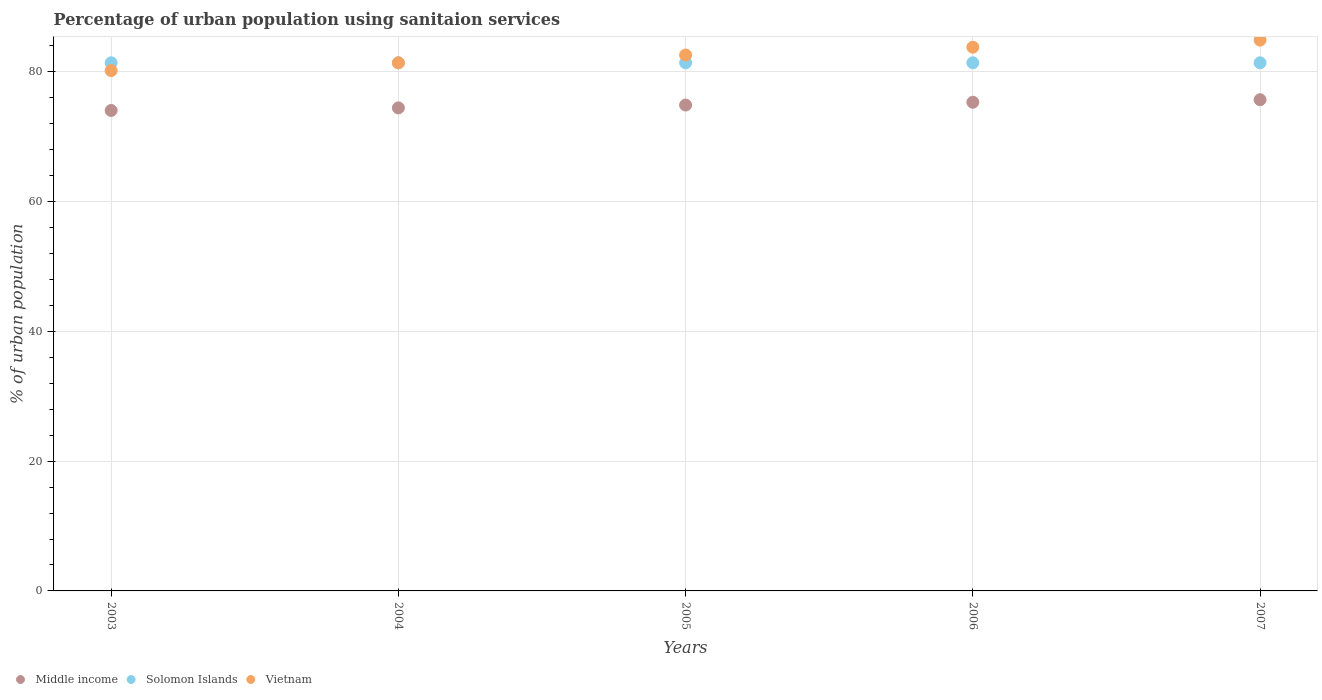What is the percentage of urban population using sanitaion services in Solomon Islands in 2005?
Ensure brevity in your answer.  81.4. Across all years, what is the maximum percentage of urban population using sanitaion services in Vietnam?
Provide a short and direct response. 84.9. Across all years, what is the minimum percentage of urban population using sanitaion services in Middle income?
Offer a very short reply. 74.05. What is the total percentage of urban population using sanitaion services in Solomon Islands in the graph?
Make the answer very short. 407. What is the difference between the percentage of urban population using sanitaion services in Solomon Islands in 2004 and that in 2007?
Make the answer very short. 0. What is the difference between the percentage of urban population using sanitaion services in Solomon Islands in 2003 and the percentage of urban population using sanitaion services in Vietnam in 2005?
Make the answer very short. -1.2. What is the average percentage of urban population using sanitaion services in Solomon Islands per year?
Your answer should be compact. 81.4. In the year 2003, what is the difference between the percentage of urban population using sanitaion services in Vietnam and percentage of urban population using sanitaion services in Solomon Islands?
Your response must be concise. -1.2. In how many years, is the percentage of urban population using sanitaion services in Vietnam greater than 28 %?
Offer a terse response. 5. Is the percentage of urban population using sanitaion services in Solomon Islands in 2003 less than that in 2004?
Offer a terse response. No. Is the sum of the percentage of urban population using sanitaion services in Solomon Islands in 2003 and 2004 greater than the maximum percentage of urban population using sanitaion services in Middle income across all years?
Ensure brevity in your answer.  Yes. Is it the case that in every year, the sum of the percentage of urban population using sanitaion services in Vietnam and percentage of urban population using sanitaion services in Middle income  is greater than the percentage of urban population using sanitaion services in Solomon Islands?
Provide a short and direct response. Yes. Does the percentage of urban population using sanitaion services in Vietnam monotonically increase over the years?
Give a very brief answer. Yes. Is the percentage of urban population using sanitaion services in Solomon Islands strictly greater than the percentage of urban population using sanitaion services in Middle income over the years?
Ensure brevity in your answer.  Yes. Is the percentage of urban population using sanitaion services in Middle income strictly less than the percentage of urban population using sanitaion services in Vietnam over the years?
Offer a very short reply. Yes. How many dotlines are there?
Offer a very short reply. 3. Where does the legend appear in the graph?
Offer a very short reply. Bottom left. How many legend labels are there?
Make the answer very short. 3. How are the legend labels stacked?
Your answer should be very brief. Horizontal. What is the title of the graph?
Keep it short and to the point. Percentage of urban population using sanitaion services. Does "Marshall Islands" appear as one of the legend labels in the graph?
Offer a very short reply. No. What is the label or title of the Y-axis?
Your answer should be compact. % of urban population. What is the % of urban population in Middle income in 2003?
Offer a terse response. 74.05. What is the % of urban population of Solomon Islands in 2003?
Your answer should be very brief. 81.4. What is the % of urban population of Vietnam in 2003?
Keep it short and to the point. 80.2. What is the % of urban population of Middle income in 2004?
Your answer should be compact. 74.45. What is the % of urban population in Solomon Islands in 2004?
Give a very brief answer. 81.4. What is the % of urban population in Vietnam in 2004?
Provide a succinct answer. 81.4. What is the % of urban population in Middle income in 2005?
Your answer should be very brief. 74.89. What is the % of urban population of Solomon Islands in 2005?
Provide a short and direct response. 81.4. What is the % of urban population in Vietnam in 2005?
Offer a very short reply. 82.6. What is the % of urban population in Middle income in 2006?
Offer a very short reply. 75.32. What is the % of urban population of Solomon Islands in 2006?
Provide a succinct answer. 81.4. What is the % of urban population of Vietnam in 2006?
Offer a very short reply. 83.8. What is the % of urban population of Middle income in 2007?
Your answer should be very brief. 75.71. What is the % of urban population of Solomon Islands in 2007?
Offer a terse response. 81.4. What is the % of urban population in Vietnam in 2007?
Provide a short and direct response. 84.9. Across all years, what is the maximum % of urban population in Middle income?
Your answer should be very brief. 75.71. Across all years, what is the maximum % of urban population in Solomon Islands?
Provide a short and direct response. 81.4. Across all years, what is the maximum % of urban population of Vietnam?
Make the answer very short. 84.9. Across all years, what is the minimum % of urban population in Middle income?
Your answer should be very brief. 74.05. Across all years, what is the minimum % of urban population in Solomon Islands?
Provide a succinct answer. 81.4. Across all years, what is the minimum % of urban population in Vietnam?
Offer a very short reply. 80.2. What is the total % of urban population of Middle income in the graph?
Provide a short and direct response. 374.42. What is the total % of urban population in Solomon Islands in the graph?
Your answer should be compact. 407. What is the total % of urban population in Vietnam in the graph?
Keep it short and to the point. 412.9. What is the difference between the % of urban population of Middle income in 2003 and that in 2004?
Provide a short and direct response. -0.4. What is the difference between the % of urban population in Solomon Islands in 2003 and that in 2004?
Give a very brief answer. 0. What is the difference between the % of urban population of Middle income in 2003 and that in 2005?
Offer a very short reply. -0.84. What is the difference between the % of urban population in Middle income in 2003 and that in 2006?
Your response must be concise. -1.27. What is the difference between the % of urban population in Solomon Islands in 2003 and that in 2006?
Ensure brevity in your answer.  0. What is the difference between the % of urban population of Middle income in 2003 and that in 2007?
Your response must be concise. -1.66. What is the difference between the % of urban population of Vietnam in 2003 and that in 2007?
Make the answer very short. -4.7. What is the difference between the % of urban population of Middle income in 2004 and that in 2005?
Keep it short and to the point. -0.44. What is the difference between the % of urban population in Solomon Islands in 2004 and that in 2005?
Your answer should be very brief. 0. What is the difference between the % of urban population of Vietnam in 2004 and that in 2005?
Offer a terse response. -1.2. What is the difference between the % of urban population of Middle income in 2004 and that in 2006?
Make the answer very short. -0.87. What is the difference between the % of urban population in Vietnam in 2004 and that in 2006?
Make the answer very short. -2.4. What is the difference between the % of urban population of Middle income in 2004 and that in 2007?
Offer a terse response. -1.26. What is the difference between the % of urban population of Solomon Islands in 2004 and that in 2007?
Give a very brief answer. 0. What is the difference between the % of urban population of Middle income in 2005 and that in 2006?
Provide a succinct answer. -0.43. What is the difference between the % of urban population in Solomon Islands in 2005 and that in 2006?
Your answer should be very brief. 0. What is the difference between the % of urban population of Middle income in 2005 and that in 2007?
Keep it short and to the point. -0.82. What is the difference between the % of urban population in Middle income in 2006 and that in 2007?
Your answer should be very brief. -0.39. What is the difference between the % of urban population in Vietnam in 2006 and that in 2007?
Your answer should be compact. -1.1. What is the difference between the % of urban population of Middle income in 2003 and the % of urban population of Solomon Islands in 2004?
Make the answer very short. -7.35. What is the difference between the % of urban population of Middle income in 2003 and the % of urban population of Vietnam in 2004?
Provide a succinct answer. -7.35. What is the difference between the % of urban population of Solomon Islands in 2003 and the % of urban population of Vietnam in 2004?
Keep it short and to the point. 0. What is the difference between the % of urban population in Middle income in 2003 and the % of urban population in Solomon Islands in 2005?
Keep it short and to the point. -7.35. What is the difference between the % of urban population of Middle income in 2003 and the % of urban population of Vietnam in 2005?
Your answer should be very brief. -8.55. What is the difference between the % of urban population of Middle income in 2003 and the % of urban population of Solomon Islands in 2006?
Provide a succinct answer. -7.35. What is the difference between the % of urban population in Middle income in 2003 and the % of urban population in Vietnam in 2006?
Keep it short and to the point. -9.75. What is the difference between the % of urban population of Solomon Islands in 2003 and the % of urban population of Vietnam in 2006?
Give a very brief answer. -2.4. What is the difference between the % of urban population in Middle income in 2003 and the % of urban population in Solomon Islands in 2007?
Your answer should be compact. -7.35. What is the difference between the % of urban population in Middle income in 2003 and the % of urban population in Vietnam in 2007?
Offer a terse response. -10.85. What is the difference between the % of urban population in Middle income in 2004 and the % of urban population in Solomon Islands in 2005?
Your response must be concise. -6.95. What is the difference between the % of urban population of Middle income in 2004 and the % of urban population of Vietnam in 2005?
Ensure brevity in your answer.  -8.15. What is the difference between the % of urban population of Solomon Islands in 2004 and the % of urban population of Vietnam in 2005?
Make the answer very short. -1.2. What is the difference between the % of urban population in Middle income in 2004 and the % of urban population in Solomon Islands in 2006?
Keep it short and to the point. -6.95. What is the difference between the % of urban population of Middle income in 2004 and the % of urban population of Vietnam in 2006?
Your response must be concise. -9.35. What is the difference between the % of urban population in Solomon Islands in 2004 and the % of urban population in Vietnam in 2006?
Ensure brevity in your answer.  -2.4. What is the difference between the % of urban population in Middle income in 2004 and the % of urban population in Solomon Islands in 2007?
Ensure brevity in your answer.  -6.95. What is the difference between the % of urban population of Middle income in 2004 and the % of urban population of Vietnam in 2007?
Your answer should be compact. -10.45. What is the difference between the % of urban population of Middle income in 2005 and the % of urban population of Solomon Islands in 2006?
Give a very brief answer. -6.51. What is the difference between the % of urban population of Middle income in 2005 and the % of urban population of Vietnam in 2006?
Provide a succinct answer. -8.91. What is the difference between the % of urban population of Middle income in 2005 and the % of urban population of Solomon Islands in 2007?
Keep it short and to the point. -6.51. What is the difference between the % of urban population of Middle income in 2005 and the % of urban population of Vietnam in 2007?
Your response must be concise. -10.01. What is the difference between the % of urban population in Middle income in 2006 and the % of urban population in Solomon Islands in 2007?
Your answer should be very brief. -6.08. What is the difference between the % of urban population of Middle income in 2006 and the % of urban population of Vietnam in 2007?
Provide a succinct answer. -9.58. What is the average % of urban population in Middle income per year?
Offer a very short reply. 74.88. What is the average % of urban population of Solomon Islands per year?
Keep it short and to the point. 81.4. What is the average % of urban population of Vietnam per year?
Provide a succinct answer. 82.58. In the year 2003, what is the difference between the % of urban population in Middle income and % of urban population in Solomon Islands?
Your answer should be compact. -7.35. In the year 2003, what is the difference between the % of urban population of Middle income and % of urban population of Vietnam?
Provide a short and direct response. -6.15. In the year 2003, what is the difference between the % of urban population of Solomon Islands and % of urban population of Vietnam?
Give a very brief answer. 1.2. In the year 2004, what is the difference between the % of urban population in Middle income and % of urban population in Solomon Islands?
Keep it short and to the point. -6.95. In the year 2004, what is the difference between the % of urban population in Middle income and % of urban population in Vietnam?
Offer a terse response. -6.95. In the year 2005, what is the difference between the % of urban population of Middle income and % of urban population of Solomon Islands?
Ensure brevity in your answer.  -6.51. In the year 2005, what is the difference between the % of urban population in Middle income and % of urban population in Vietnam?
Make the answer very short. -7.71. In the year 2005, what is the difference between the % of urban population in Solomon Islands and % of urban population in Vietnam?
Offer a very short reply. -1.2. In the year 2006, what is the difference between the % of urban population of Middle income and % of urban population of Solomon Islands?
Your response must be concise. -6.08. In the year 2006, what is the difference between the % of urban population in Middle income and % of urban population in Vietnam?
Ensure brevity in your answer.  -8.48. In the year 2006, what is the difference between the % of urban population of Solomon Islands and % of urban population of Vietnam?
Provide a short and direct response. -2.4. In the year 2007, what is the difference between the % of urban population of Middle income and % of urban population of Solomon Islands?
Give a very brief answer. -5.69. In the year 2007, what is the difference between the % of urban population in Middle income and % of urban population in Vietnam?
Your answer should be compact. -9.19. What is the ratio of the % of urban population in Solomon Islands in 2003 to that in 2004?
Ensure brevity in your answer.  1. What is the ratio of the % of urban population in Vietnam in 2003 to that in 2004?
Provide a succinct answer. 0.99. What is the ratio of the % of urban population of Solomon Islands in 2003 to that in 2005?
Ensure brevity in your answer.  1. What is the ratio of the % of urban population in Vietnam in 2003 to that in 2005?
Ensure brevity in your answer.  0.97. What is the ratio of the % of urban population of Middle income in 2003 to that in 2006?
Provide a short and direct response. 0.98. What is the ratio of the % of urban population of Solomon Islands in 2003 to that in 2006?
Make the answer very short. 1. What is the ratio of the % of urban population in Middle income in 2003 to that in 2007?
Give a very brief answer. 0.98. What is the ratio of the % of urban population of Vietnam in 2003 to that in 2007?
Provide a short and direct response. 0.94. What is the ratio of the % of urban population of Solomon Islands in 2004 to that in 2005?
Your response must be concise. 1. What is the ratio of the % of urban population in Vietnam in 2004 to that in 2005?
Keep it short and to the point. 0.99. What is the ratio of the % of urban population of Vietnam in 2004 to that in 2006?
Keep it short and to the point. 0.97. What is the ratio of the % of urban population in Middle income in 2004 to that in 2007?
Make the answer very short. 0.98. What is the ratio of the % of urban population of Vietnam in 2004 to that in 2007?
Your answer should be compact. 0.96. What is the ratio of the % of urban population in Middle income in 2005 to that in 2006?
Provide a succinct answer. 0.99. What is the ratio of the % of urban population of Solomon Islands in 2005 to that in 2006?
Keep it short and to the point. 1. What is the ratio of the % of urban population in Vietnam in 2005 to that in 2006?
Provide a short and direct response. 0.99. What is the ratio of the % of urban population of Middle income in 2005 to that in 2007?
Offer a very short reply. 0.99. What is the ratio of the % of urban population in Solomon Islands in 2005 to that in 2007?
Ensure brevity in your answer.  1. What is the ratio of the % of urban population of Vietnam in 2005 to that in 2007?
Make the answer very short. 0.97. What is the ratio of the % of urban population of Solomon Islands in 2006 to that in 2007?
Your response must be concise. 1. What is the difference between the highest and the second highest % of urban population in Middle income?
Your answer should be compact. 0.39. What is the difference between the highest and the lowest % of urban population of Middle income?
Your answer should be compact. 1.66. 